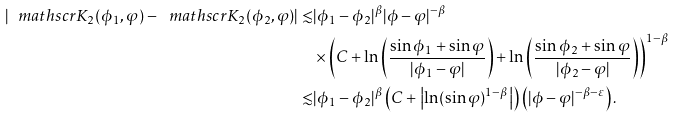Convert formula to latex. <formula><loc_0><loc_0><loc_500><loc_500>| \ m a t h s c r { K } _ { 2 } ( \phi _ { 1 } , \varphi ) - \ m a t h s c r { K } _ { 2 } ( \phi _ { 2 } , \varphi ) | \lesssim & | \phi _ { 1 } - \phi _ { 2 } | ^ { \beta } { | \phi - \varphi | ^ { - \beta } } \\ & \times \left ( C + \ln \left ( \frac { \sin \phi _ { 1 } + \sin \varphi } { | \phi _ { 1 } - \varphi | } \right ) + \ln \left ( \frac { \sin \phi _ { 2 } + \sin \varphi } { | \phi _ { 2 } - \varphi | } \right ) \right ) ^ { 1 - \beta } \\ \lesssim & | \phi _ { 1 } - \phi _ { 2 } | ^ { \beta } \left ( C + \left | \ln ( \sin \varphi ) ^ { 1 - \beta } \right | \right ) \left ( { | \phi - \varphi | ^ { - \beta - \varepsilon } } \right ) .</formula> 